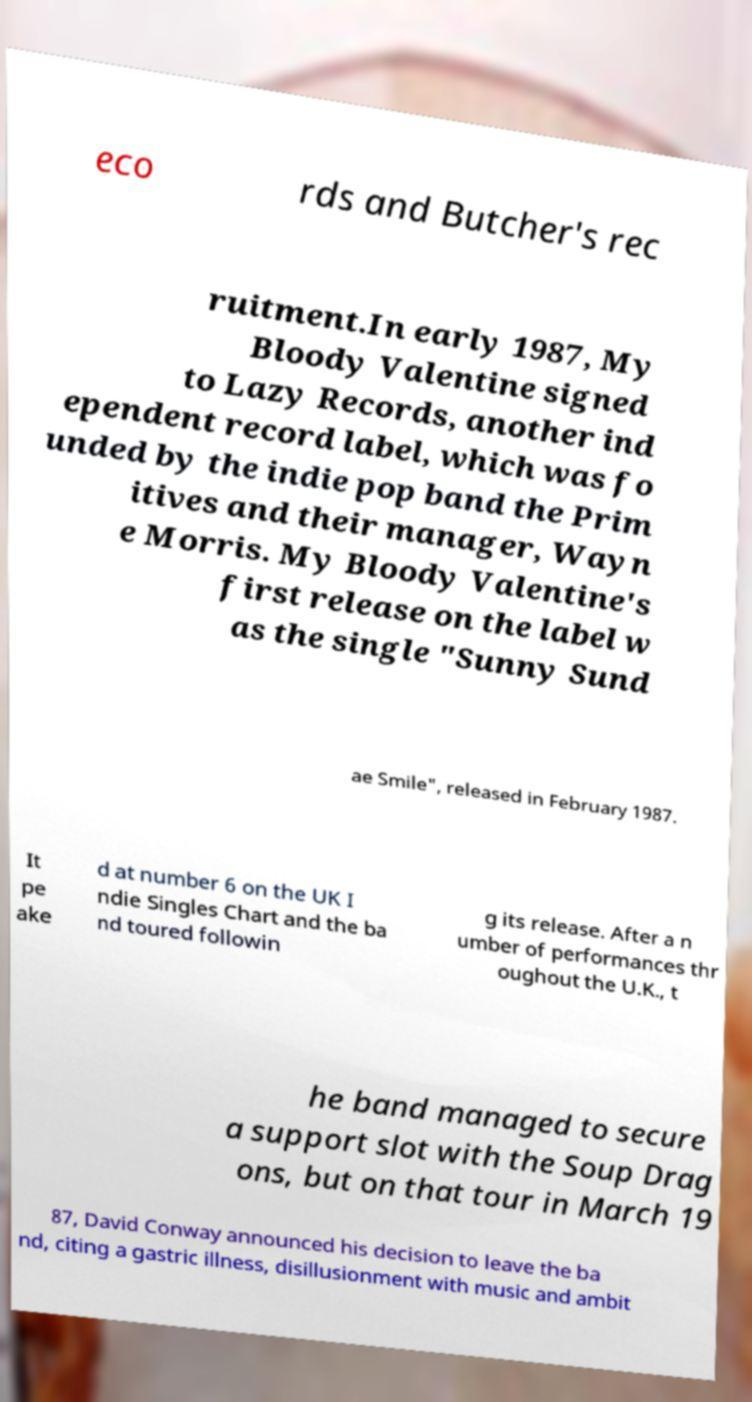Can you accurately transcribe the text from the provided image for me? eco rds and Butcher's rec ruitment.In early 1987, My Bloody Valentine signed to Lazy Records, another ind ependent record label, which was fo unded by the indie pop band the Prim itives and their manager, Wayn e Morris. My Bloody Valentine's first release on the label w as the single "Sunny Sund ae Smile", released in February 1987. It pe ake d at number 6 on the UK I ndie Singles Chart and the ba nd toured followin g its release. After a n umber of performances thr oughout the U.K., t he band managed to secure a support slot with the Soup Drag ons, but on that tour in March 19 87, David Conway announced his decision to leave the ba nd, citing a gastric illness, disillusionment with music and ambit 